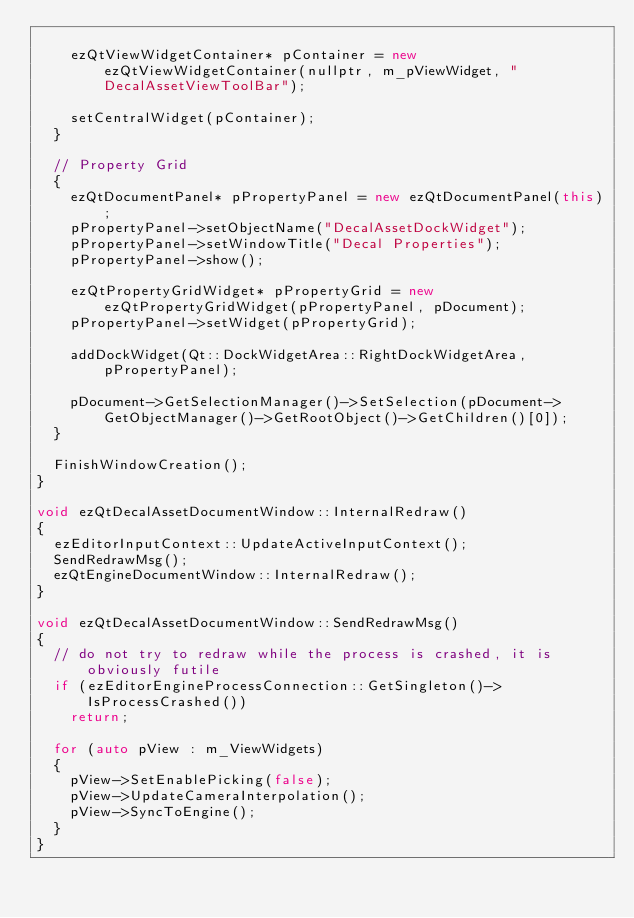Convert code to text. <code><loc_0><loc_0><loc_500><loc_500><_C++_>
    ezQtViewWidgetContainer* pContainer = new ezQtViewWidgetContainer(nullptr, m_pViewWidget, "DecalAssetViewToolBar");

    setCentralWidget(pContainer);
  }

  // Property Grid
  {
    ezQtDocumentPanel* pPropertyPanel = new ezQtDocumentPanel(this);
    pPropertyPanel->setObjectName("DecalAssetDockWidget");
    pPropertyPanel->setWindowTitle("Decal Properties");
    pPropertyPanel->show();

    ezQtPropertyGridWidget* pPropertyGrid = new ezQtPropertyGridWidget(pPropertyPanel, pDocument);
    pPropertyPanel->setWidget(pPropertyGrid);

    addDockWidget(Qt::DockWidgetArea::RightDockWidgetArea, pPropertyPanel);

    pDocument->GetSelectionManager()->SetSelection(pDocument->GetObjectManager()->GetRootObject()->GetChildren()[0]);
  }

  FinishWindowCreation();
}

void ezQtDecalAssetDocumentWindow::InternalRedraw()
{
  ezEditorInputContext::UpdateActiveInputContext();
  SendRedrawMsg();
  ezQtEngineDocumentWindow::InternalRedraw();
}

void ezQtDecalAssetDocumentWindow::SendRedrawMsg()
{
  // do not try to redraw while the process is crashed, it is obviously futile
  if (ezEditorEngineProcessConnection::GetSingleton()->IsProcessCrashed())
    return;

  for (auto pView : m_ViewWidgets)
  {
    pView->SetEnablePicking(false);
    pView->UpdateCameraInterpolation();
    pView->SyncToEngine();
  }
}
</code> 